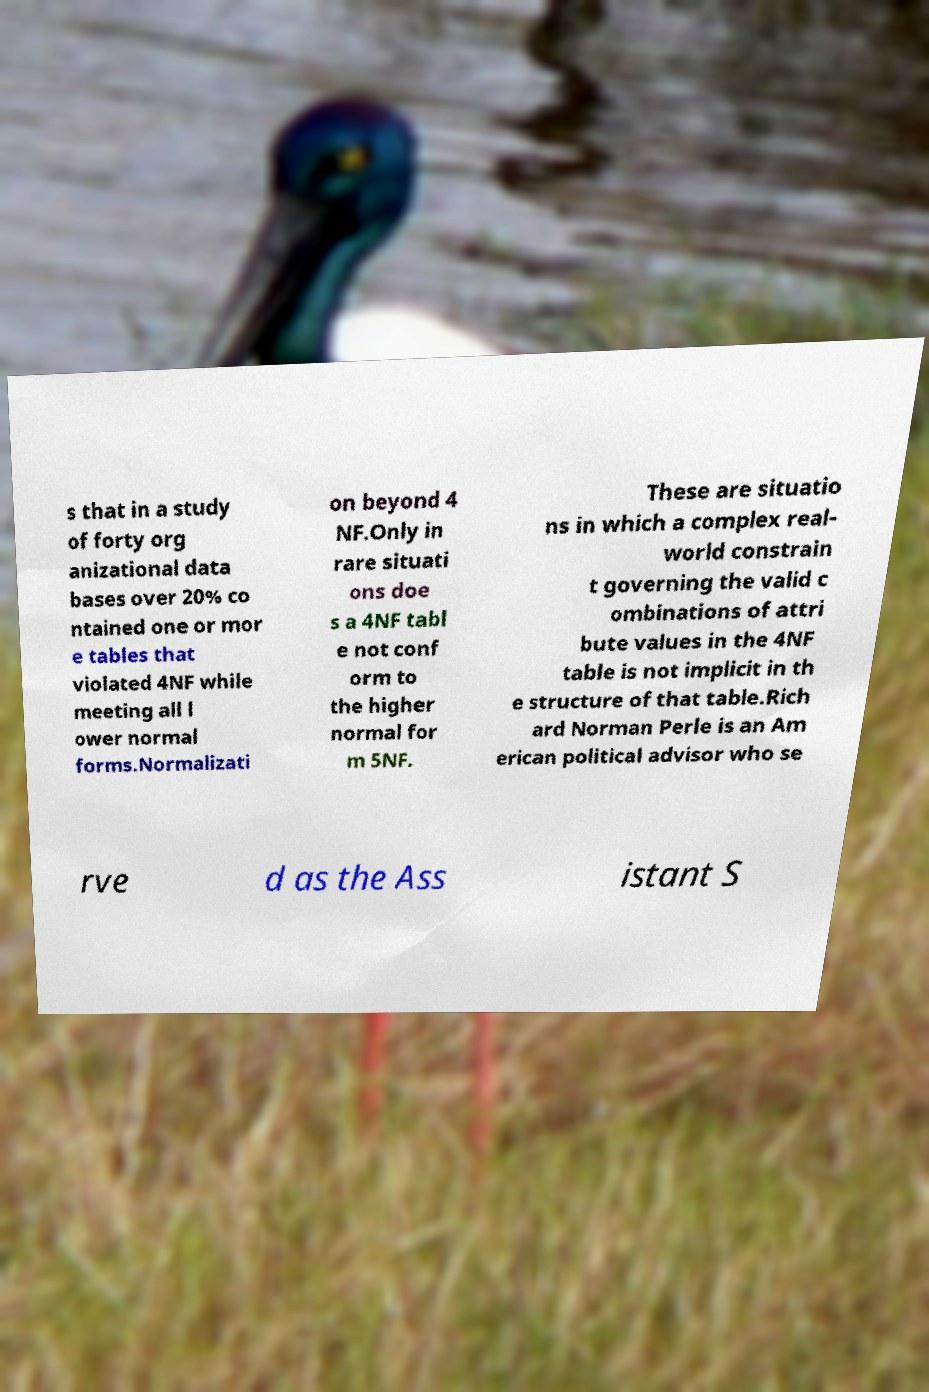For documentation purposes, I need the text within this image transcribed. Could you provide that? s that in a study of forty org anizational data bases over 20% co ntained one or mor e tables that violated 4NF while meeting all l ower normal forms.Normalizati on beyond 4 NF.Only in rare situati ons doe s a 4NF tabl e not conf orm to the higher normal for m 5NF. These are situatio ns in which a complex real- world constrain t governing the valid c ombinations of attri bute values in the 4NF table is not implicit in th e structure of that table.Rich ard Norman Perle is an Am erican political advisor who se rve d as the Ass istant S 